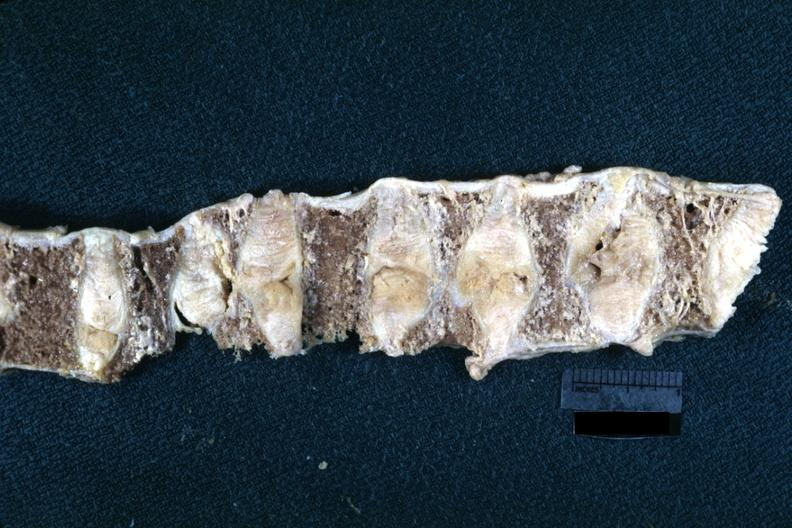s joints present?
Answer the question using a single word or phrase. Yes 